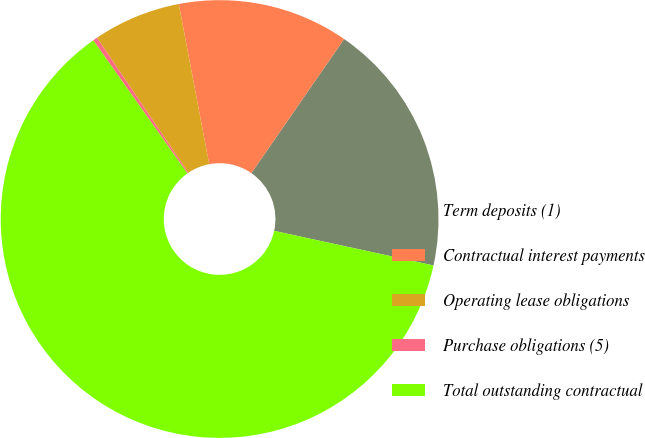<chart> <loc_0><loc_0><loc_500><loc_500><pie_chart><fcel>Term deposits (1)<fcel>Contractual interest payments<fcel>Operating lease obligations<fcel>Purchase obligations (5)<fcel>Total outstanding contractual<nl><fcel>18.77%<fcel>12.62%<fcel>6.48%<fcel>0.33%<fcel>61.8%<nl></chart> 